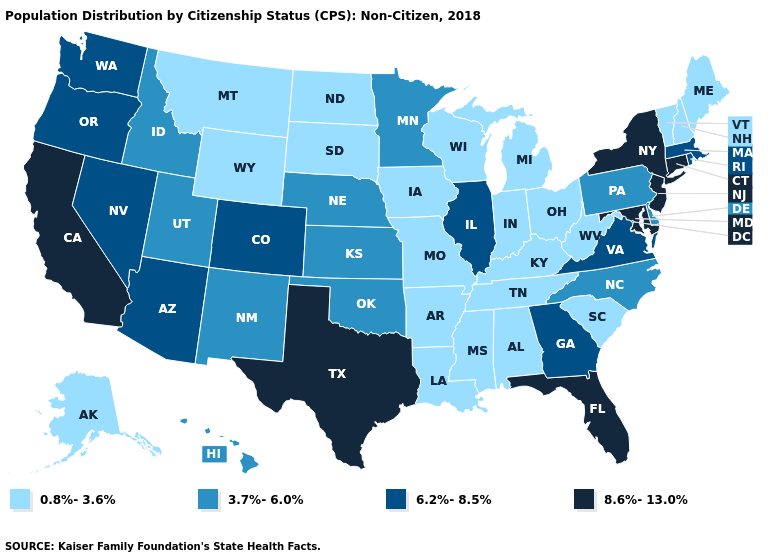Among the states that border Virginia , which have the lowest value?
Be succinct. Kentucky, Tennessee, West Virginia. Does Mississippi have the lowest value in the USA?
Be succinct. Yes. What is the value of Texas?
Concise answer only. 8.6%-13.0%. Does Alaska have the lowest value in the USA?
Give a very brief answer. Yes. Is the legend a continuous bar?
Give a very brief answer. No. What is the highest value in the South ?
Keep it brief. 8.6%-13.0%. What is the value of Nevada?
Quick response, please. 6.2%-8.5%. Does Maryland have the highest value in the USA?
Answer briefly. Yes. What is the value of North Carolina?
Answer briefly. 3.7%-6.0%. Does Idaho have the highest value in the USA?
Be succinct. No. Does Minnesota have the lowest value in the USA?
Keep it brief. No. Name the states that have a value in the range 6.2%-8.5%?
Write a very short answer. Arizona, Colorado, Georgia, Illinois, Massachusetts, Nevada, Oregon, Rhode Island, Virginia, Washington. What is the value of Maine?
Give a very brief answer. 0.8%-3.6%. Which states have the lowest value in the MidWest?
Quick response, please. Indiana, Iowa, Michigan, Missouri, North Dakota, Ohio, South Dakota, Wisconsin. Does Vermont have the lowest value in the USA?
Quick response, please. Yes. 